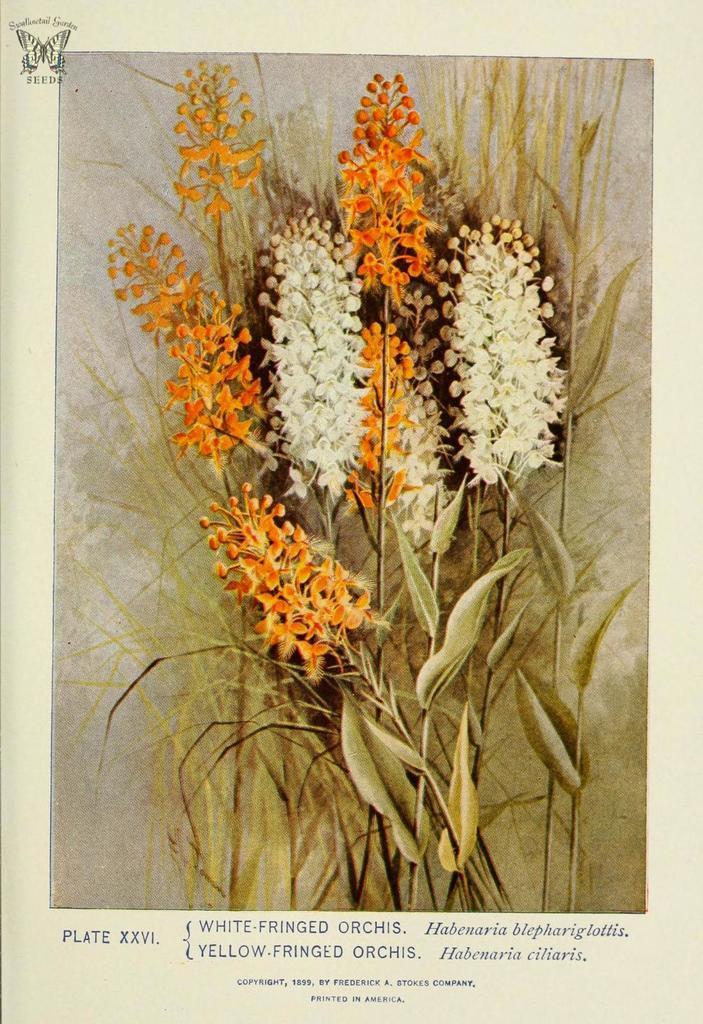Could you give a brief overview of what you see in this image? In this image I can see few white and orange color flowers and dry leaves. Something is written on the image. 